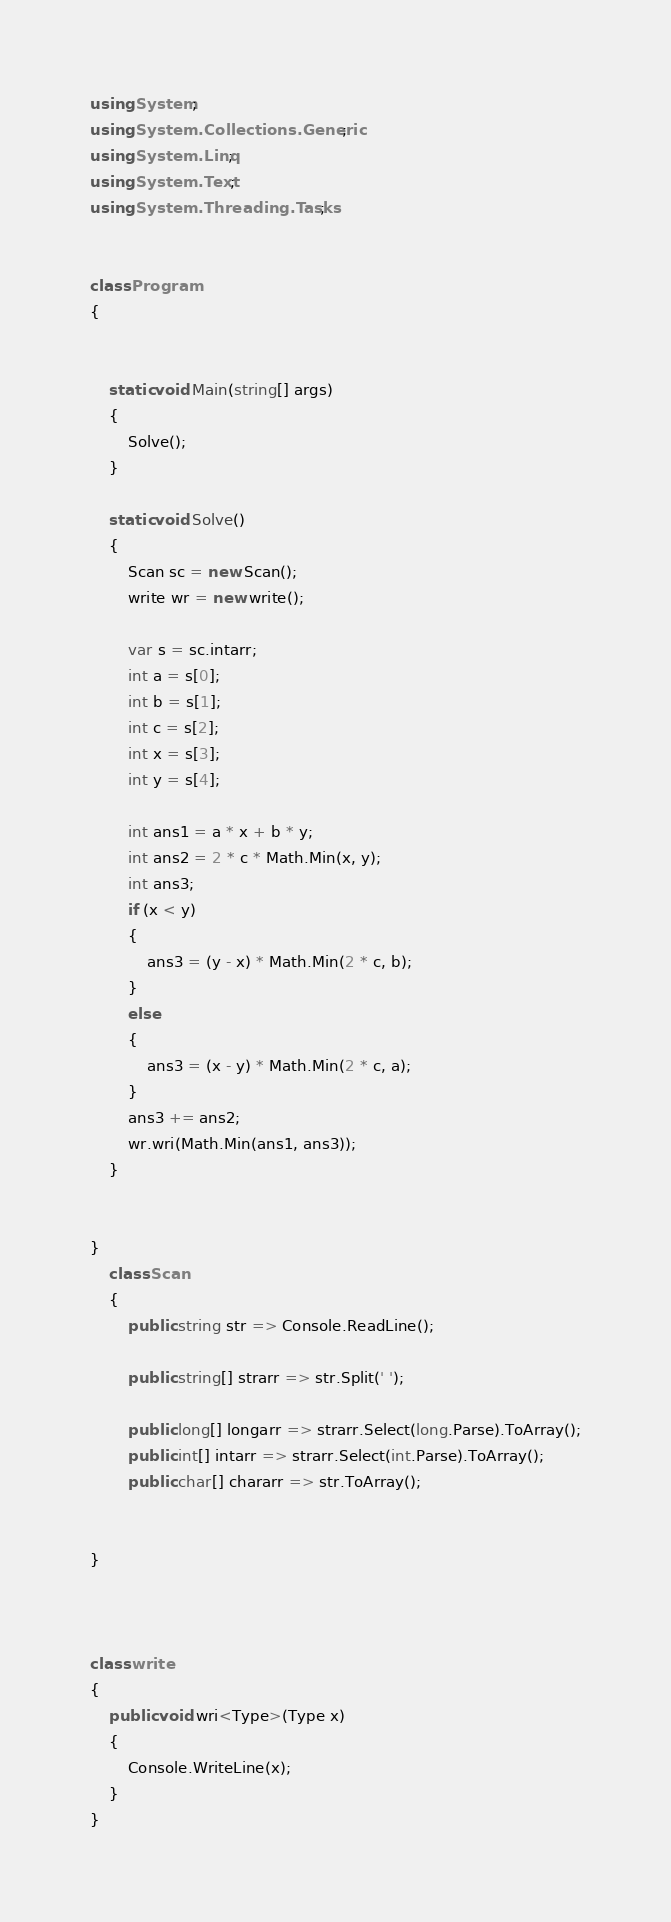Convert code to text. <code><loc_0><loc_0><loc_500><loc_500><_C#_>using System;
using System.Collections.Generic;
using System.Linq;
using System.Text;
using System.Threading.Tasks;


class Program
{


    static void Main(string[] args)
    {
        Solve();
    }

    static void Solve()
    {
        Scan sc = new Scan();
        write wr = new write();

        var s = sc.intarr;
        int a = s[0];
        int b = s[1];
        int c = s[2];
        int x = s[3];
        int y = s[4];

        int ans1 = a * x + b * y;
        int ans2 = 2 * c * Math.Min(x, y);
        int ans3;
        if (x < y)
        {
            ans3 = (y - x) * Math.Min(2 * c, b);
        }
        else
        {
            ans3 = (x - y) * Math.Min(2 * c, a);
        }
        ans3 += ans2;
        wr.wri(Math.Min(ans1, ans3));
    }


}
    class Scan
    {
        public string str => Console.ReadLine();

        public string[] strarr => str.Split(' ');

        public long[] longarr => strarr.Select(long.Parse).ToArray();
        public int[] intarr => strarr.Select(int.Parse).ToArray();
        public char[] chararr => str.ToArray();


}



class write
{
    public void wri<Type>(Type x)
    {
        Console.WriteLine(x);
    }
}
</code> 